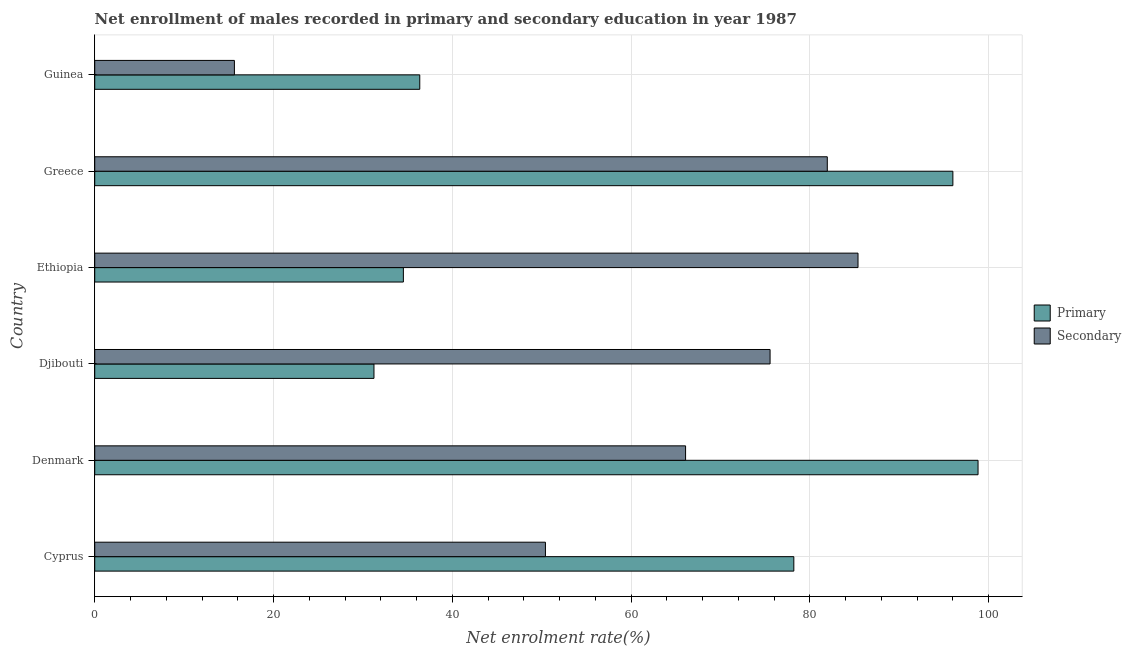Are the number of bars per tick equal to the number of legend labels?
Provide a short and direct response. Yes. Are the number of bars on each tick of the Y-axis equal?
Offer a very short reply. Yes. What is the label of the 6th group of bars from the top?
Provide a succinct answer. Cyprus. In how many cases, is the number of bars for a given country not equal to the number of legend labels?
Provide a succinct answer. 0. What is the enrollment rate in secondary education in Greece?
Provide a succinct answer. 81.95. Across all countries, what is the maximum enrollment rate in secondary education?
Your answer should be very brief. 85.39. Across all countries, what is the minimum enrollment rate in secondary education?
Your response must be concise. 15.63. In which country was the enrollment rate in primary education minimum?
Ensure brevity in your answer.  Djibouti. What is the total enrollment rate in secondary education in the graph?
Ensure brevity in your answer.  375.03. What is the difference between the enrollment rate in primary education in Cyprus and that in Djibouti?
Keep it short and to the point. 46.97. What is the difference between the enrollment rate in primary education in Cyprus and the enrollment rate in secondary education in Denmark?
Make the answer very short. 12.11. What is the average enrollment rate in secondary education per country?
Provide a succinct answer. 62.51. What is the difference between the enrollment rate in primary education and enrollment rate in secondary education in Guinea?
Ensure brevity in your answer.  20.74. In how many countries, is the enrollment rate in primary education greater than 88 %?
Offer a very short reply. 2. What is the ratio of the enrollment rate in secondary education in Cyprus to that in Denmark?
Offer a terse response. 0.76. Is the difference between the enrollment rate in secondary education in Ethiopia and Greece greater than the difference between the enrollment rate in primary education in Ethiopia and Greece?
Your answer should be compact. Yes. What is the difference between the highest and the second highest enrollment rate in primary education?
Provide a succinct answer. 2.81. What is the difference between the highest and the lowest enrollment rate in secondary education?
Provide a short and direct response. 69.76. In how many countries, is the enrollment rate in primary education greater than the average enrollment rate in primary education taken over all countries?
Your answer should be compact. 3. What does the 2nd bar from the top in Denmark represents?
Offer a very short reply. Primary. What does the 2nd bar from the bottom in Guinea represents?
Give a very brief answer. Secondary. How many countries are there in the graph?
Make the answer very short. 6. What is the difference between two consecutive major ticks on the X-axis?
Your answer should be compact. 20. Are the values on the major ticks of X-axis written in scientific E-notation?
Offer a very short reply. No. Where does the legend appear in the graph?
Your answer should be very brief. Center right. How many legend labels are there?
Give a very brief answer. 2. What is the title of the graph?
Your response must be concise. Net enrollment of males recorded in primary and secondary education in year 1987. Does "Measles" appear as one of the legend labels in the graph?
Give a very brief answer. No. What is the label or title of the X-axis?
Your response must be concise. Net enrolment rate(%). What is the Net enrolment rate(%) in Primary in Cyprus?
Your answer should be compact. 78.21. What is the Net enrolment rate(%) of Secondary in Cyprus?
Provide a short and direct response. 50.42. What is the Net enrolment rate(%) of Primary in Denmark?
Your response must be concise. 98.82. What is the Net enrolment rate(%) in Secondary in Denmark?
Provide a short and direct response. 66.1. What is the Net enrolment rate(%) of Primary in Djibouti?
Your response must be concise. 31.24. What is the Net enrolment rate(%) of Secondary in Djibouti?
Keep it short and to the point. 75.55. What is the Net enrolment rate(%) in Primary in Ethiopia?
Give a very brief answer. 34.53. What is the Net enrolment rate(%) of Secondary in Ethiopia?
Make the answer very short. 85.39. What is the Net enrolment rate(%) in Primary in Greece?
Offer a terse response. 96. What is the Net enrolment rate(%) of Secondary in Greece?
Make the answer very short. 81.95. What is the Net enrolment rate(%) in Primary in Guinea?
Make the answer very short. 36.36. What is the Net enrolment rate(%) of Secondary in Guinea?
Make the answer very short. 15.63. Across all countries, what is the maximum Net enrolment rate(%) of Primary?
Your answer should be compact. 98.82. Across all countries, what is the maximum Net enrolment rate(%) in Secondary?
Your response must be concise. 85.39. Across all countries, what is the minimum Net enrolment rate(%) in Primary?
Your response must be concise. 31.24. Across all countries, what is the minimum Net enrolment rate(%) of Secondary?
Your answer should be compact. 15.63. What is the total Net enrolment rate(%) of Primary in the graph?
Make the answer very short. 375.15. What is the total Net enrolment rate(%) of Secondary in the graph?
Offer a terse response. 375.03. What is the difference between the Net enrolment rate(%) of Primary in Cyprus and that in Denmark?
Offer a terse response. -20.61. What is the difference between the Net enrolment rate(%) of Secondary in Cyprus and that in Denmark?
Provide a short and direct response. -15.68. What is the difference between the Net enrolment rate(%) in Primary in Cyprus and that in Djibouti?
Offer a very short reply. 46.97. What is the difference between the Net enrolment rate(%) in Secondary in Cyprus and that in Djibouti?
Your answer should be compact. -25.13. What is the difference between the Net enrolment rate(%) in Primary in Cyprus and that in Ethiopia?
Offer a terse response. 43.68. What is the difference between the Net enrolment rate(%) of Secondary in Cyprus and that in Ethiopia?
Keep it short and to the point. -34.97. What is the difference between the Net enrolment rate(%) in Primary in Cyprus and that in Greece?
Keep it short and to the point. -17.79. What is the difference between the Net enrolment rate(%) of Secondary in Cyprus and that in Greece?
Provide a short and direct response. -31.53. What is the difference between the Net enrolment rate(%) in Primary in Cyprus and that in Guinea?
Make the answer very short. 41.85. What is the difference between the Net enrolment rate(%) in Secondary in Cyprus and that in Guinea?
Your response must be concise. 34.79. What is the difference between the Net enrolment rate(%) of Primary in Denmark and that in Djibouti?
Provide a succinct answer. 67.58. What is the difference between the Net enrolment rate(%) of Secondary in Denmark and that in Djibouti?
Give a very brief answer. -9.45. What is the difference between the Net enrolment rate(%) in Primary in Denmark and that in Ethiopia?
Ensure brevity in your answer.  64.29. What is the difference between the Net enrolment rate(%) in Secondary in Denmark and that in Ethiopia?
Your answer should be compact. -19.29. What is the difference between the Net enrolment rate(%) of Primary in Denmark and that in Greece?
Give a very brief answer. 2.82. What is the difference between the Net enrolment rate(%) of Secondary in Denmark and that in Greece?
Your answer should be very brief. -15.85. What is the difference between the Net enrolment rate(%) in Primary in Denmark and that in Guinea?
Offer a very short reply. 62.45. What is the difference between the Net enrolment rate(%) of Secondary in Denmark and that in Guinea?
Give a very brief answer. 50.47. What is the difference between the Net enrolment rate(%) of Primary in Djibouti and that in Ethiopia?
Offer a terse response. -3.29. What is the difference between the Net enrolment rate(%) in Secondary in Djibouti and that in Ethiopia?
Make the answer very short. -9.84. What is the difference between the Net enrolment rate(%) of Primary in Djibouti and that in Greece?
Keep it short and to the point. -64.76. What is the difference between the Net enrolment rate(%) in Secondary in Djibouti and that in Greece?
Give a very brief answer. -6.4. What is the difference between the Net enrolment rate(%) of Primary in Djibouti and that in Guinea?
Your answer should be compact. -5.12. What is the difference between the Net enrolment rate(%) in Secondary in Djibouti and that in Guinea?
Keep it short and to the point. 59.92. What is the difference between the Net enrolment rate(%) in Primary in Ethiopia and that in Greece?
Give a very brief answer. -61.47. What is the difference between the Net enrolment rate(%) in Secondary in Ethiopia and that in Greece?
Offer a terse response. 3.44. What is the difference between the Net enrolment rate(%) in Primary in Ethiopia and that in Guinea?
Keep it short and to the point. -1.83. What is the difference between the Net enrolment rate(%) in Secondary in Ethiopia and that in Guinea?
Offer a very short reply. 69.76. What is the difference between the Net enrolment rate(%) in Primary in Greece and that in Guinea?
Make the answer very short. 59.64. What is the difference between the Net enrolment rate(%) in Secondary in Greece and that in Guinea?
Make the answer very short. 66.33. What is the difference between the Net enrolment rate(%) in Primary in Cyprus and the Net enrolment rate(%) in Secondary in Denmark?
Your answer should be very brief. 12.11. What is the difference between the Net enrolment rate(%) of Primary in Cyprus and the Net enrolment rate(%) of Secondary in Djibouti?
Offer a terse response. 2.66. What is the difference between the Net enrolment rate(%) in Primary in Cyprus and the Net enrolment rate(%) in Secondary in Ethiopia?
Offer a terse response. -7.18. What is the difference between the Net enrolment rate(%) in Primary in Cyprus and the Net enrolment rate(%) in Secondary in Greece?
Keep it short and to the point. -3.74. What is the difference between the Net enrolment rate(%) of Primary in Cyprus and the Net enrolment rate(%) of Secondary in Guinea?
Offer a very short reply. 62.58. What is the difference between the Net enrolment rate(%) of Primary in Denmark and the Net enrolment rate(%) of Secondary in Djibouti?
Ensure brevity in your answer.  23.27. What is the difference between the Net enrolment rate(%) in Primary in Denmark and the Net enrolment rate(%) in Secondary in Ethiopia?
Ensure brevity in your answer.  13.43. What is the difference between the Net enrolment rate(%) of Primary in Denmark and the Net enrolment rate(%) of Secondary in Greece?
Make the answer very short. 16.86. What is the difference between the Net enrolment rate(%) of Primary in Denmark and the Net enrolment rate(%) of Secondary in Guinea?
Your answer should be compact. 83.19. What is the difference between the Net enrolment rate(%) of Primary in Djibouti and the Net enrolment rate(%) of Secondary in Ethiopia?
Provide a succinct answer. -54.15. What is the difference between the Net enrolment rate(%) of Primary in Djibouti and the Net enrolment rate(%) of Secondary in Greece?
Keep it short and to the point. -50.71. What is the difference between the Net enrolment rate(%) of Primary in Djibouti and the Net enrolment rate(%) of Secondary in Guinea?
Provide a short and direct response. 15.61. What is the difference between the Net enrolment rate(%) in Primary in Ethiopia and the Net enrolment rate(%) in Secondary in Greece?
Keep it short and to the point. -47.42. What is the difference between the Net enrolment rate(%) in Primary in Ethiopia and the Net enrolment rate(%) in Secondary in Guinea?
Provide a short and direct response. 18.9. What is the difference between the Net enrolment rate(%) in Primary in Greece and the Net enrolment rate(%) in Secondary in Guinea?
Your answer should be compact. 80.37. What is the average Net enrolment rate(%) in Primary per country?
Keep it short and to the point. 62.53. What is the average Net enrolment rate(%) in Secondary per country?
Your answer should be compact. 62.51. What is the difference between the Net enrolment rate(%) of Primary and Net enrolment rate(%) of Secondary in Cyprus?
Provide a succinct answer. 27.79. What is the difference between the Net enrolment rate(%) in Primary and Net enrolment rate(%) in Secondary in Denmark?
Provide a short and direct response. 32.72. What is the difference between the Net enrolment rate(%) in Primary and Net enrolment rate(%) in Secondary in Djibouti?
Your response must be concise. -44.31. What is the difference between the Net enrolment rate(%) of Primary and Net enrolment rate(%) of Secondary in Ethiopia?
Offer a very short reply. -50.86. What is the difference between the Net enrolment rate(%) of Primary and Net enrolment rate(%) of Secondary in Greece?
Give a very brief answer. 14.05. What is the difference between the Net enrolment rate(%) of Primary and Net enrolment rate(%) of Secondary in Guinea?
Make the answer very short. 20.74. What is the ratio of the Net enrolment rate(%) in Primary in Cyprus to that in Denmark?
Provide a short and direct response. 0.79. What is the ratio of the Net enrolment rate(%) of Secondary in Cyprus to that in Denmark?
Provide a short and direct response. 0.76. What is the ratio of the Net enrolment rate(%) in Primary in Cyprus to that in Djibouti?
Provide a short and direct response. 2.5. What is the ratio of the Net enrolment rate(%) in Secondary in Cyprus to that in Djibouti?
Your response must be concise. 0.67. What is the ratio of the Net enrolment rate(%) of Primary in Cyprus to that in Ethiopia?
Your response must be concise. 2.27. What is the ratio of the Net enrolment rate(%) of Secondary in Cyprus to that in Ethiopia?
Give a very brief answer. 0.59. What is the ratio of the Net enrolment rate(%) of Primary in Cyprus to that in Greece?
Provide a short and direct response. 0.81. What is the ratio of the Net enrolment rate(%) in Secondary in Cyprus to that in Greece?
Keep it short and to the point. 0.62. What is the ratio of the Net enrolment rate(%) of Primary in Cyprus to that in Guinea?
Your answer should be very brief. 2.15. What is the ratio of the Net enrolment rate(%) in Secondary in Cyprus to that in Guinea?
Ensure brevity in your answer.  3.23. What is the ratio of the Net enrolment rate(%) of Primary in Denmark to that in Djibouti?
Your answer should be compact. 3.16. What is the ratio of the Net enrolment rate(%) in Secondary in Denmark to that in Djibouti?
Offer a terse response. 0.87. What is the ratio of the Net enrolment rate(%) in Primary in Denmark to that in Ethiopia?
Provide a succinct answer. 2.86. What is the ratio of the Net enrolment rate(%) in Secondary in Denmark to that in Ethiopia?
Ensure brevity in your answer.  0.77. What is the ratio of the Net enrolment rate(%) in Primary in Denmark to that in Greece?
Offer a terse response. 1.03. What is the ratio of the Net enrolment rate(%) in Secondary in Denmark to that in Greece?
Your answer should be very brief. 0.81. What is the ratio of the Net enrolment rate(%) of Primary in Denmark to that in Guinea?
Keep it short and to the point. 2.72. What is the ratio of the Net enrolment rate(%) in Secondary in Denmark to that in Guinea?
Your response must be concise. 4.23. What is the ratio of the Net enrolment rate(%) of Primary in Djibouti to that in Ethiopia?
Provide a succinct answer. 0.9. What is the ratio of the Net enrolment rate(%) in Secondary in Djibouti to that in Ethiopia?
Make the answer very short. 0.88. What is the ratio of the Net enrolment rate(%) of Primary in Djibouti to that in Greece?
Give a very brief answer. 0.33. What is the ratio of the Net enrolment rate(%) in Secondary in Djibouti to that in Greece?
Keep it short and to the point. 0.92. What is the ratio of the Net enrolment rate(%) of Primary in Djibouti to that in Guinea?
Make the answer very short. 0.86. What is the ratio of the Net enrolment rate(%) of Secondary in Djibouti to that in Guinea?
Offer a terse response. 4.83. What is the ratio of the Net enrolment rate(%) of Primary in Ethiopia to that in Greece?
Make the answer very short. 0.36. What is the ratio of the Net enrolment rate(%) in Secondary in Ethiopia to that in Greece?
Offer a terse response. 1.04. What is the ratio of the Net enrolment rate(%) in Primary in Ethiopia to that in Guinea?
Your answer should be compact. 0.95. What is the ratio of the Net enrolment rate(%) in Secondary in Ethiopia to that in Guinea?
Ensure brevity in your answer.  5.46. What is the ratio of the Net enrolment rate(%) in Primary in Greece to that in Guinea?
Your answer should be very brief. 2.64. What is the ratio of the Net enrolment rate(%) in Secondary in Greece to that in Guinea?
Make the answer very short. 5.24. What is the difference between the highest and the second highest Net enrolment rate(%) in Primary?
Your response must be concise. 2.82. What is the difference between the highest and the second highest Net enrolment rate(%) of Secondary?
Your answer should be very brief. 3.44. What is the difference between the highest and the lowest Net enrolment rate(%) in Primary?
Offer a terse response. 67.58. What is the difference between the highest and the lowest Net enrolment rate(%) in Secondary?
Give a very brief answer. 69.76. 